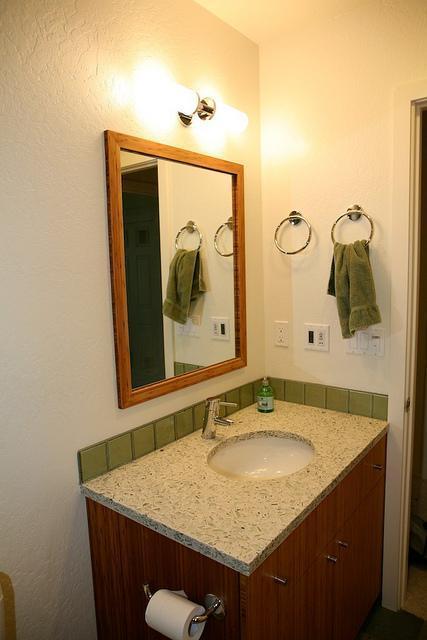How many towel holders are there?
Give a very brief answer. 2. How many handles are on the left side of the bathroom cabinet?
Give a very brief answer. 1. How many light fixtures are in this picture?
Give a very brief answer. 1. How many towels are hanging?
Give a very brief answer. 1. How many faucets?
Give a very brief answer. 1. How many lamps are in the bathroom?
Give a very brief answer. 1. 